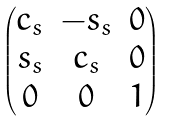Convert formula to latex. <formula><loc_0><loc_0><loc_500><loc_500>\begin{pmatrix} c _ { s } & - s _ { s } & 0 \\ s _ { s } & c _ { s } & 0 \\ 0 & 0 & 1 \end{pmatrix}</formula> 